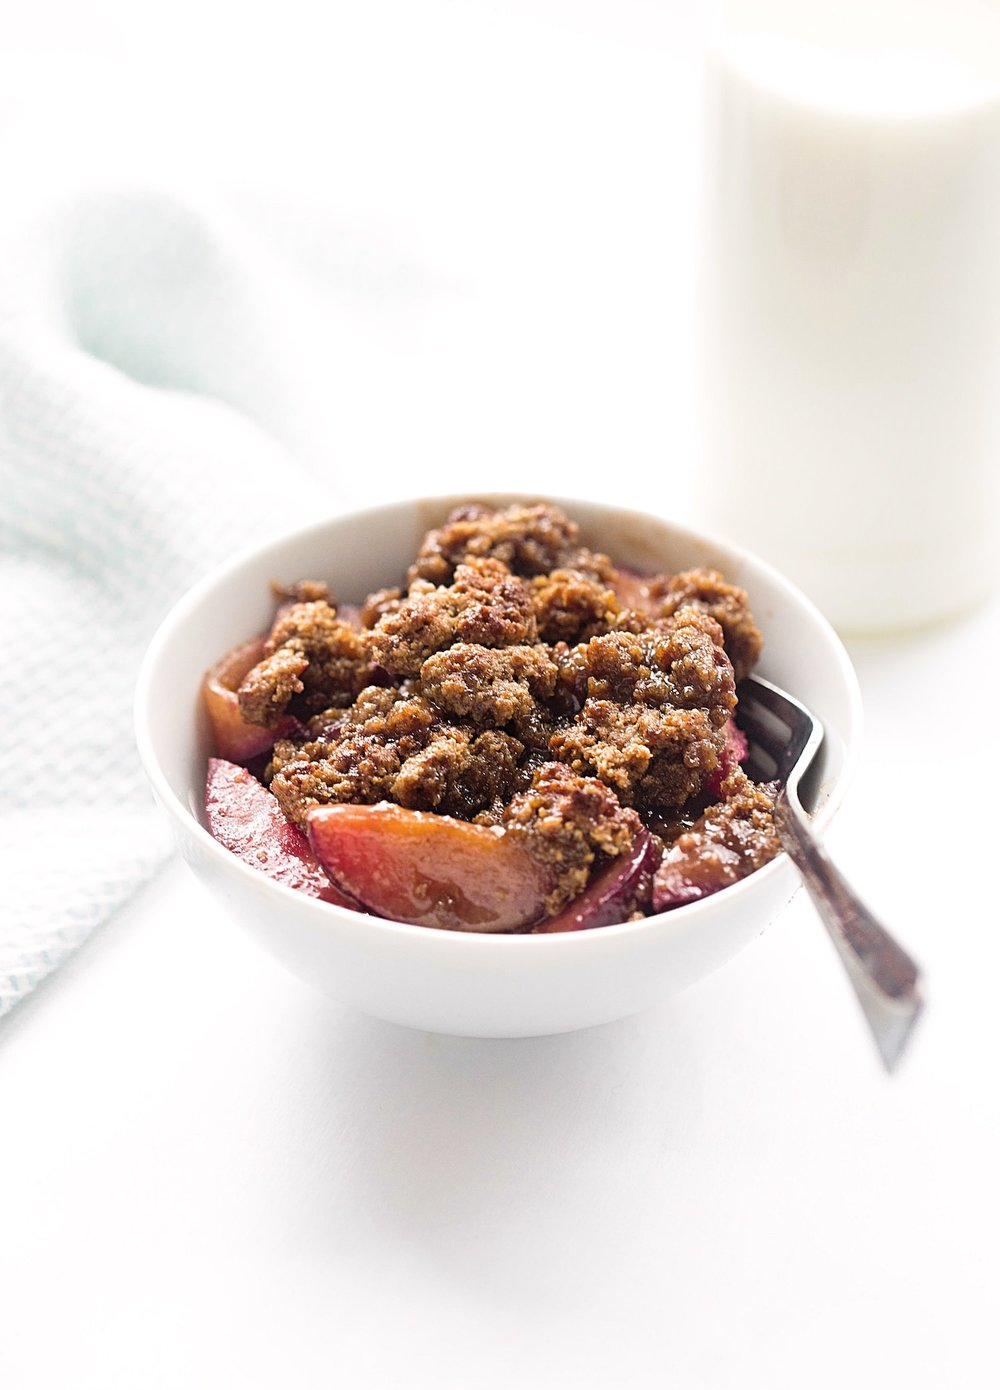How would you suggest serving this dessert if it were part of a dinner party? For a dinner party, I'd serve this delectable crumble warm, possibly with a scoop of vanilla ice cream or a dollop of whipped cream. Offering it in individual ramekins can add an elegant touch, and a sprig of mint or a light dusting of powdered sugar could provide a visually appealing garnish. 